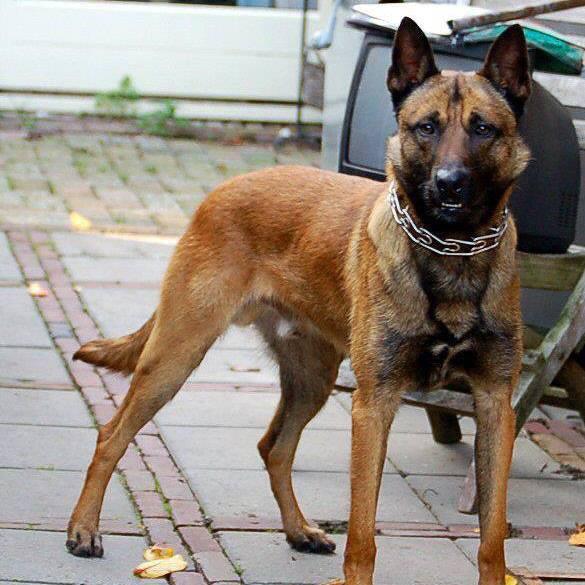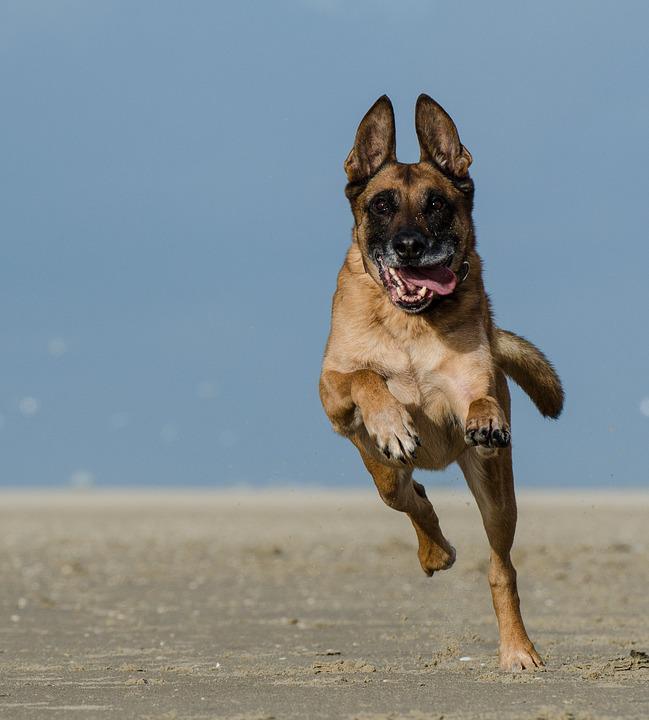The first image is the image on the left, the second image is the image on the right. Analyze the images presented: Is the assertion "One dog stands and looks directly towards camera." valid? Answer yes or no. Yes. 